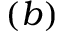Convert formula to latex. <formula><loc_0><loc_0><loc_500><loc_500>( b )</formula> 